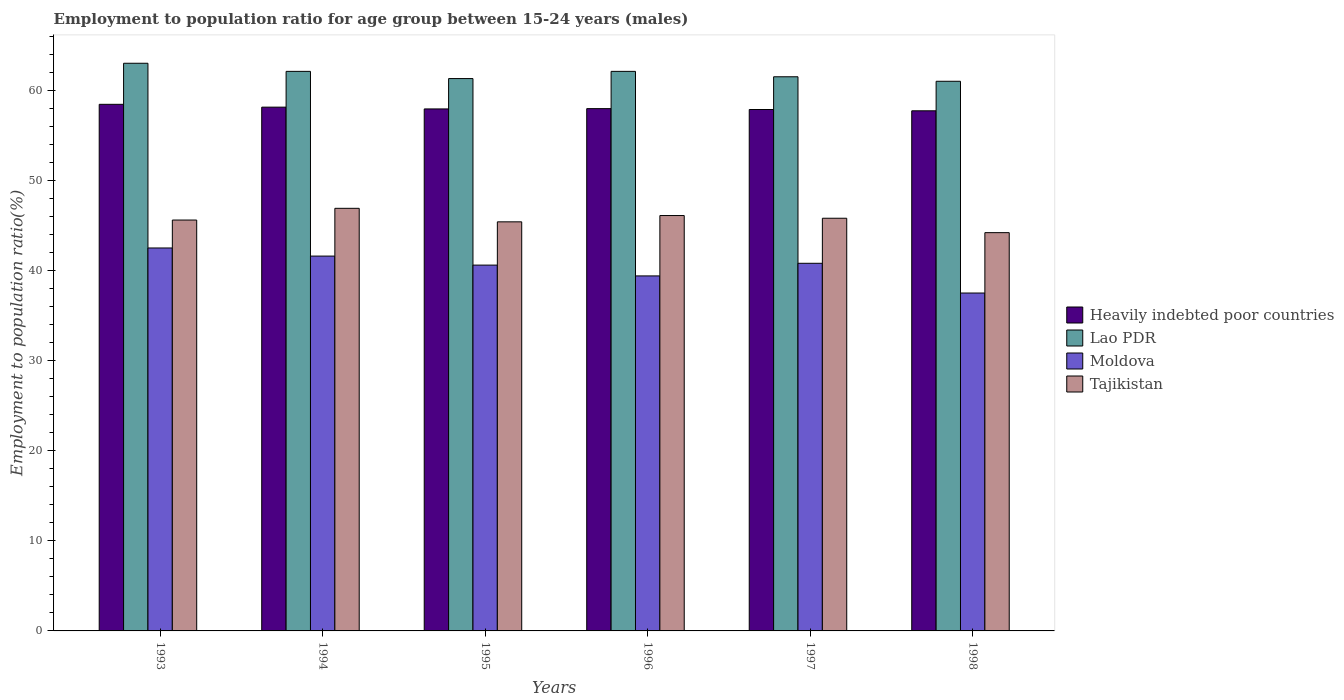Are the number of bars per tick equal to the number of legend labels?
Your answer should be very brief. Yes. Are the number of bars on each tick of the X-axis equal?
Make the answer very short. Yes. How many bars are there on the 4th tick from the left?
Provide a short and direct response. 4. What is the label of the 5th group of bars from the left?
Offer a very short reply. 1997. In how many cases, is the number of bars for a given year not equal to the number of legend labels?
Your response must be concise. 0. What is the employment to population ratio in Tajikistan in 1995?
Your answer should be very brief. 45.4. Across all years, what is the maximum employment to population ratio in Tajikistan?
Make the answer very short. 46.9. Across all years, what is the minimum employment to population ratio in Moldova?
Make the answer very short. 37.5. In which year was the employment to population ratio in Moldova maximum?
Give a very brief answer. 1993. What is the total employment to population ratio in Tajikistan in the graph?
Make the answer very short. 274. What is the difference between the employment to population ratio in Lao PDR in 1994 and that in 1996?
Offer a terse response. 0. What is the difference between the employment to population ratio in Moldova in 1998 and the employment to population ratio in Lao PDR in 1996?
Offer a terse response. -24.6. What is the average employment to population ratio in Moldova per year?
Your answer should be very brief. 40.4. In the year 1996, what is the difference between the employment to population ratio in Lao PDR and employment to population ratio in Heavily indebted poor countries?
Provide a succinct answer. 4.14. In how many years, is the employment to population ratio in Moldova greater than 22 %?
Make the answer very short. 6. What is the ratio of the employment to population ratio in Lao PDR in 1993 to that in 1998?
Provide a short and direct response. 1.03. What is the difference between the highest and the second highest employment to population ratio in Heavily indebted poor countries?
Ensure brevity in your answer.  0.31. What is the difference between the highest and the lowest employment to population ratio in Moldova?
Ensure brevity in your answer.  5. Is the sum of the employment to population ratio in Heavily indebted poor countries in 1993 and 1996 greater than the maximum employment to population ratio in Lao PDR across all years?
Offer a very short reply. Yes. Is it the case that in every year, the sum of the employment to population ratio in Moldova and employment to population ratio in Lao PDR is greater than the sum of employment to population ratio in Tajikistan and employment to population ratio in Heavily indebted poor countries?
Your response must be concise. No. What does the 1st bar from the left in 1997 represents?
Give a very brief answer. Heavily indebted poor countries. What does the 4th bar from the right in 1996 represents?
Make the answer very short. Heavily indebted poor countries. Are all the bars in the graph horizontal?
Keep it short and to the point. No. How many years are there in the graph?
Provide a short and direct response. 6. Where does the legend appear in the graph?
Provide a succinct answer. Center right. How many legend labels are there?
Give a very brief answer. 4. How are the legend labels stacked?
Your response must be concise. Vertical. What is the title of the graph?
Provide a succinct answer. Employment to population ratio for age group between 15-24 years (males). What is the Employment to population ratio(%) in Heavily indebted poor countries in 1993?
Your answer should be very brief. 58.44. What is the Employment to population ratio(%) of Moldova in 1993?
Offer a terse response. 42.5. What is the Employment to population ratio(%) in Tajikistan in 1993?
Offer a terse response. 45.6. What is the Employment to population ratio(%) of Heavily indebted poor countries in 1994?
Your answer should be very brief. 58.13. What is the Employment to population ratio(%) of Lao PDR in 1994?
Keep it short and to the point. 62.1. What is the Employment to population ratio(%) in Moldova in 1994?
Offer a terse response. 41.6. What is the Employment to population ratio(%) of Tajikistan in 1994?
Provide a succinct answer. 46.9. What is the Employment to population ratio(%) of Heavily indebted poor countries in 1995?
Keep it short and to the point. 57.93. What is the Employment to population ratio(%) in Lao PDR in 1995?
Provide a short and direct response. 61.3. What is the Employment to population ratio(%) of Moldova in 1995?
Provide a succinct answer. 40.6. What is the Employment to population ratio(%) in Tajikistan in 1995?
Offer a terse response. 45.4. What is the Employment to population ratio(%) in Heavily indebted poor countries in 1996?
Offer a very short reply. 57.96. What is the Employment to population ratio(%) of Lao PDR in 1996?
Your answer should be very brief. 62.1. What is the Employment to population ratio(%) in Moldova in 1996?
Offer a very short reply. 39.4. What is the Employment to population ratio(%) of Tajikistan in 1996?
Provide a short and direct response. 46.1. What is the Employment to population ratio(%) in Heavily indebted poor countries in 1997?
Your answer should be very brief. 57.87. What is the Employment to population ratio(%) in Lao PDR in 1997?
Provide a succinct answer. 61.5. What is the Employment to population ratio(%) in Moldova in 1997?
Your answer should be very brief. 40.8. What is the Employment to population ratio(%) of Tajikistan in 1997?
Your response must be concise. 45.8. What is the Employment to population ratio(%) of Heavily indebted poor countries in 1998?
Your response must be concise. 57.72. What is the Employment to population ratio(%) in Moldova in 1998?
Give a very brief answer. 37.5. What is the Employment to population ratio(%) in Tajikistan in 1998?
Offer a terse response. 44.2. Across all years, what is the maximum Employment to population ratio(%) in Heavily indebted poor countries?
Provide a short and direct response. 58.44. Across all years, what is the maximum Employment to population ratio(%) of Moldova?
Your response must be concise. 42.5. Across all years, what is the maximum Employment to population ratio(%) of Tajikistan?
Make the answer very short. 46.9. Across all years, what is the minimum Employment to population ratio(%) in Heavily indebted poor countries?
Keep it short and to the point. 57.72. Across all years, what is the minimum Employment to population ratio(%) in Lao PDR?
Keep it short and to the point. 61. Across all years, what is the minimum Employment to population ratio(%) in Moldova?
Your answer should be very brief. 37.5. Across all years, what is the minimum Employment to population ratio(%) in Tajikistan?
Your answer should be very brief. 44.2. What is the total Employment to population ratio(%) of Heavily indebted poor countries in the graph?
Offer a very short reply. 348.06. What is the total Employment to population ratio(%) in Lao PDR in the graph?
Offer a terse response. 371. What is the total Employment to population ratio(%) of Moldova in the graph?
Provide a succinct answer. 242.4. What is the total Employment to population ratio(%) in Tajikistan in the graph?
Offer a terse response. 274. What is the difference between the Employment to population ratio(%) in Heavily indebted poor countries in 1993 and that in 1994?
Offer a terse response. 0.31. What is the difference between the Employment to population ratio(%) of Moldova in 1993 and that in 1994?
Give a very brief answer. 0.9. What is the difference between the Employment to population ratio(%) in Heavily indebted poor countries in 1993 and that in 1995?
Give a very brief answer. 0.51. What is the difference between the Employment to population ratio(%) in Heavily indebted poor countries in 1993 and that in 1996?
Your answer should be compact. 0.48. What is the difference between the Employment to population ratio(%) of Lao PDR in 1993 and that in 1996?
Your answer should be compact. 0.9. What is the difference between the Employment to population ratio(%) of Tajikistan in 1993 and that in 1996?
Make the answer very short. -0.5. What is the difference between the Employment to population ratio(%) in Heavily indebted poor countries in 1993 and that in 1997?
Give a very brief answer. 0.57. What is the difference between the Employment to population ratio(%) of Lao PDR in 1993 and that in 1997?
Offer a very short reply. 1.5. What is the difference between the Employment to population ratio(%) of Heavily indebted poor countries in 1993 and that in 1998?
Provide a short and direct response. 0.72. What is the difference between the Employment to population ratio(%) in Tajikistan in 1993 and that in 1998?
Your answer should be very brief. 1.4. What is the difference between the Employment to population ratio(%) of Heavily indebted poor countries in 1994 and that in 1995?
Ensure brevity in your answer.  0.2. What is the difference between the Employment to population ratio(%) in Moldova in 1994 and that in 1995?
Provide a succinct answer. 1. What is the difference between the Employment to population ratio(%) in Heavily indebted poor countries in 1994 and that in 1996?
Ensure brevity in your answer.  0.16. What is the difference between the Employment to population ratio(%) of Lao PDR in 1994 and that in 1996?
Keep it short and to the point. 0. What is the difference between the Employment to population ratio(%) of Moldova in 1994 and that in 1996?
Your response must be concise. 2.2. What is the difference between the Employment to population ratio(%) in Tajikistan in 1994 and that in 1996?
Your answer should be very brief. 0.8. What is the difference between the Employment to population ratio(%) of Heavily indebted poor countries in 1994 and that in 1997?
Keep it short and to the point. 0.26. What is the difference between the Employment to population ratio(%) in Lao PDR in 1994 and that in 1997?
Your response must be concise. 0.6. What is the difference between the Employment to population ratio(%) of Moldova in 1994 and that in 1997?
Your answer should be very brief. 0.8. What is the difference between the Employment to population ratio(%) in Tajikistan in 1994 and that in 1997?
Keep it short and to the point. 1.1. What is the difference between the Employment to population ratio(%) of Heavily indebted poor countries in 1994 and that in 1998?
Give a very brief answer. 0.41. What is the difference between the Employment to population ratio(%) of Moldova in 1994 and that in 1998?
Your response must be concise. 4.1. What is the difference between the Employment to population ratio(%) in Tajikistan in 1994 and that in 1998?
Provide a short and direct response. 2.7. What is the difference between the Employment to population ratio(%) of Heavily indebted poor countries in 1995 and that in 1996?
Your response must be concise. -0.03. What is the difference between the Employment to population ratio(%) of Tajikistan in 1995 and that in 1996?
Your answer should be very brief. -0.7. What is the difference between the Employment to population ratio(%) of Heavily indebted poor countries in 1995 and that in 1997?
Make the answer very short. 0.06. What is the difference between the Employment to population ratio(%) of Lao PDR in 1995 and that in 1997?
Your answer should be compact. -0.2. What is the difference between the Employment to population ratio(%) of Moldova in 1995 and that in 1997?
Ensure brevity in your answer.  -0.2. What is the difference between the Employment to population ratio(%) in Tajikistan in 1995 and that in 1997?
Your answer should be compact. -0.4. What is the difference between the Employment to population ratio(%) in Heavily indebted poor countries in 1995 and that in 1998?
Keep it short and to the point. 0.21. What is the difference between the Employment to population ratio(%) in Moldova in 1995 and that in 1998?
Keep it short and to the point. 3.1. What is the difference between the Employment to population ratio(%) in Tajikistan in 1995 and that in 1998?
Your answer should be compact. 1.2. What is the difference between the Employment to population ratio(%) in Heavily indebted poor countries in 1996 and that in 1997?
Offer a very short reply. 0.1. What is the difference between the Employment to population ratio(%) of Lao PDR in 1996 and that in 1997?
Provide a short and direct response. 0.6. What is the difference between the Employment to population ratio(%) in Moldova in 1996 and that in 1997?
Ensure brevity in your answer.  -1.4. What is the difference between the Employment to population ratio(%) of Tajikistan in 1996 and that in 1997?
Provide a short and direct response. 0.3. What is the difference between the Employment to population ratio(%) of Heavily indebted poor countries in 1996 and that in 1998?
Provide a short and direct response. 0.24. What is the difference between the Employment to population ratio(%) in Lao PDR in 1996 and that in 1998?
Give a very brief answer. 1.1. What is the difference between the Employment to population ratio(%) of Moldova in 1996 and that in 1998?
Your answer should be very brief. 1.9. What is the difference between the Employment to population ratio(%) of Tajikistan in 1996 and that in 1998?
Your answer should be very brief. 1.9. What is the difference between the Employment to population ratio(%) in Heavily indebted poor countries in 1997 and that in 1998?
Your response must be concise. 0.14. What is the difference between the Employment to population ratio(%) in Lao PDR in 1997 and that in 1998?
Your response must be concise. 0.5. What is the difference between the Employment to population ratio(%) of Moldova in 1997 and that in 1998?
Ensure brevity in your answer.  3.3. What is the difference between the Employment to population ratio(%) in Tajikistan in 1997 and that in 1998?
Ensure brevity in your answer.  1.6. What is the difference between the Employment to population ratio(%) in Heavily indebted poor countries in 1993 and the Employment to population ratio(%) in Lao PDR in 1994?
Your answer should be very brief. -3.66. What is the difference between the Employment to population ratio(%) in Heavily indebted poor countries in 1993 and the Employment to population ratio(%) in Moldova in 1994?
Your answer should be compact. 16.84. What is the difference between the Employment to population ratio(%) of Heavily indebted poor countries in 1993 and the Employment to population ratio(%) of Tajikistan in 1994?
Offer a terse response. 11.54. What is the difference between the Employment to population ratio(%) of Lao PDR in 1993 and the Employment to population ratio(%) of Moldova in 1994?
Your response must be concise. 21.4. What is the difference between the Employment to population ratio(%) in Moldova in 1993 and the Employment to population ratio(%) in Tajikistan in 1994?
Provide a short and direct response. -4.4. What is the difference between the Employment to population ratio(%) in Heavily indebted poor countries in 1993 and the Employment to population ratio(%) in Lao PDR in 1995?
Offer a terse response. -2.86. What is the difference between the Employment to population ratio(%) in Heavily indebted poor countries in 1993 and the Employment to population ratio(%) in Moldova in 1995?
Ensure brevity in your answer.  17.84. What is the difference between the Employment to population ratio(%) of Heavily indebted poor countries in 1993 and the Employment to population ratio(%) of Tajikistan in 1995?
Give a very brief answer. 13.04. What is the difference between the Employment to population ratio(%) in Lao PDR in 1993 and the Employment to population ratio(%) in Moldova in 1995?
Offer a terse response. 22.4. What is the difference between the Employment to population ratio(%) of Heavily indebted poor countries in 1993 and the Employment to population ratio(%) of Lao PDR in 1996?
Offer a terse response. -3.66. What is the difference between the Employment to population ratio(%) of Heavily indebted poor countries in 1993 and the Employment to population ratio(%) of Moldova in 1996?
Provide a short and direct response. 19.04. What is the difference between the Employment to population ratio(%) of Heavily indebted poor countries in 1993 and the Employment to population ratio(%) of Tajikistan in 1996?
Your response must be concise. 12.34. What is the difference between the Employment to population ratio(%) of Lao PDR in 1993 and the Employment to population ratio(%) of Moldova in 1996?
Give a very brief answer. 23.6. What is the difference between the Employment to population ratio(%) of Lao PDR in 1993 and the Employment to population ratio(%) of Tajikistan in 1996?
Your response must be concise. 16.9. What is the difference between the Employment to population ratio(%) in Heavily indebted poor countries in 1993 and the Employment to population ratio(%) in Lao PDR in 1997?
Make the answer very short. -3.06. What is the difference between the Employment to population ratio(%) of Heavily indebted poor countries in 1993 and the Employment to population ratio(%) of Moldova in 1997?
Offer a very short reply. 17.64. What is the difference between the Employment to population ratio(%) in Heavily indebted poor countries in 1993 and the Employment to population ratio(%) in Tajikistan in 1997?
Offer a very short reply. 12.64. What is the difference between the Employment to population ratio(%) in Heavily indebted poor countries in 1993 and the Employment to population ratio(%) in Lao PDR in 1998?
Your answer should be compact. -2.56. What is the difference between the Employment to population ratio(%) of Heavily indebted poor countries in 1993 and the Employment to population ratio(%) of Moldova in 1998?
Make the answer very short. 20.94. What is the difference between the Employment to population ratio(%) in Heavily indebted poor countries in 1993 and the Employment to population ratio(%) in Tajikistan in 1998?
Offer a terse response. 14.24. What is the difference between the Employment to population ratio(%) of Heavily indebted poor countries in 1994 and the Employment to population ratio(%) of Lao PDR in 1995?
Give a very brief answer. -3.17. What is the difference between the Employment to population ratio(%) of Heavily indebted poor countries in 1994 and the Employment to population ratio(%) of Moldova in 1995?
Give a very brief answer. 17.53. What is the difference between the Employment to population ratio(%) in Heavily indebted poor countries in 1994 and the Employment to population ratio(%) in Tajikistan in 1995?
Offer a terse response. 12.73. What is the difference between the Employment to population ratio(%) in Lao PDR in 1994 and the Employment to population ratio(%) in Moldova in 1995?
Give a very brief answer. 21.5. What is the difference between the Employment to population ratio(%) in Moldova in 1994 and the Employment to population ratio(%) in Tajikistan in 1995?
Offer a very short reply. -3.8. What is the difference between the Employment to population ratio(%) in Heavily indebted poor countries in 1994 and the Employment to population ratio(%) in Lao PDR in 1996?
Ensure brevity in your answer.  -3.97. What is the difference between the Employment to population ratio(%) of Heavily indebted poor countries in 1994 and the Employment to population ratio(%) of Moldova in 1996?
Provide a succinct answer. 18.73. What is the difference between the Employment to population ratio(%) in Heavily indebted poor countries in 1994 and the Employment to population ratio(%) in Tajikistan in 1996?
Your answer should be compact. 12.03. What is the difference between the Employment to population ratio(%) in Lao PDR in 1994 and the Employment to population ratio(%) in Moldova in 1996?
Your response must be concise. 22.7. What is the difference between the Employment to population ratio(%) of Heavily indebted poor countries in 1994 and the Employment to population ratio(%) of Lao PDR in 1997?
Offer a very short reply. -3.37. What is the difference between the Employment to population ratio(%) of Heavily indebted poor countries in 1994 and the Employment to population ratio(%) of Moldova in 1997?
Make the answer very short. 17.33. What is the difference between the Employment to population ratio(%) in Heavily indebted poor countries in 1994 and the Employment to population ratio(%) in Tajikistan in 1997?
Your answer should be very brief. 12.33. What is the difference between the Employment to population ratio(%) in Lao PDR in 1994 and the Employment to population ratio(%) in Moldova in 1997?
Provide a succinct answer. 21.3. What is the difference between the Employment to population ratio(%) of Heavily indebted poor countries in 1994 and the Employment to population ratio(%) of Lao PDR in 1998?
Provide a short and direct response. -2.87. What is the difference between the Employment to population ratio(%) in Heavily indebted poor countries in 1994 and the Employment to population ratio(%) in Moldova in 1998?
Offer a terse response. 20.63. What is the difference between the Employment to population ratio(%) of Heavily indebted poor countries in 1994 and the Employment to population ratio(%) of Tajikistan in 1998?
Your response must be concise. 13.93. What is the difference between the Employment to population ratio(%) of Lao PDR in 1994 and the Employment to population ratio(%) of Moldova in 1998?
Give a very brief answer. 24.6. What is the difference between the Employment to population ratio(%) of Moldova in 1994 and the Employment to population ratio(%) of Tajikistan in 1998?
Offer a terse response. -2.6. What is the difference between the Employment to population ratio(%) of Heavily indebted poor countries in 1995 and the Employment to population ratio(%) of Lao PDR in 1996?
Offer a terse response. -4.17. What is the difference between the Employment to population ratio(%) in Heavily indebted poor countries in 1995 and the Employment to population ratio(%) in Moldova in 1996?
Your response must be concise. 18.53. What is the difference between the Employment to population ratio(%) of Heavily indebted poor countries in 1995 and the Employment to population ratio(%) of Tajikistan in 1996?
Your answer should be compact. 11.83. What is the difference between the Employment to population ratio(%) of Lao PDR in 1995 and the Employment to population ratio(%) of Moldova in 1996?
Your response must be concise. 21.9. What is the difference between the Employment to population ratio(%) in Heavily indebted poor countries in 1995 and the Employment to population ratio(%) in Lao PDR in 1997?
Offer a terse response. -3.57. What is the difference between the Employment to population ratio(%) of Heavily indebted poor countries in 1995 and the Employment to population ratio(%) of Moldova in 1997?
Keep it short and to the point. 17.13. What is the difference between the Employment to population ratio(%) in Heavily indebted poor countries in 1995 and the Employment to population ratio(%) in Tajikistan in 1997?
Offer a terse response. 12.13. What is the difference between the Employment to population ratio(%) in Lao PDR in 1995 and the Employment to population ratio(%) in Moldova in 1997?
Your answer should be very brief. 20.5. What is the difference between the Employment to population ratio(%) of Lao PDR in 1995 and the Employment to population ratio(%) of Tajikistan in 1997?
Offer a very short reply. 15.5. What is the difference between the Employment to population ratio(%) in Heavily indebted poor countries in 1995 and the Employment to population ratio(%) in Lao PDR in 1998?
Your response must be concise. -3.07. What is the difference between the Employment to population ratio(%) of Heavily indebted poor countries in 1995 and the Employment to population ratio(%) of Moldova in 1998?
Your answer should be compact. 20.43. What is the difference between the Employment to population ratio(%) in Heavily indebted poor countries in 1995 and the Employment to population ratio(%) in Tajikistan in 1998?
Give a very brief answer. 13.73. What is the difference between the Employment to population ratio(%) in Lao PDR in 1995 and the Employment to population ratio(%) in Moldova in 1998?
Offer a terse response. 23.8. What is the difference between the Employment to population ratio(%) in Lao PDR in 1995 and the Employment to population ratio(%) in Tajikistan in 1998?
Offer a terse response. 17.1. What is the difference between the Employment to population ratio(%) in Moldova in 1995 and the Employment to population ratio(%) in Tajikistan in 1998?
Offer a terse response. -3.6. What is the difference between the Employment to population ratio(%) of Heavily indebted poor countries in 1996 and the Employment to population ratio(%) of Lao PDR in 1997?
Give a very brief answer. -3.54. What is the difference between the Employment to population ratio(%) of Heavily indebted poor countries in 1996 and the Employment to population ratio(%) of Moldova in 1997?
Keep it short and to the point. 17.16. What is the difference between the Employment to population ratio(%) in Heavily indebted poor countries in 1996 and the Employment to population ratio(%) in Tajikistan in 1997?
Provide a short and direct response. 12.16. What is the difference between the Employment to population ratio(%) of Lao PDR in 1996 and the Employment to population ratio(%) of Moldova in 1997?
Offer a very short reply. 21.3. What is the difference between the Employment to population ratio(%) of Heavily indebted poor countries in 1996 and the Employment to population ratio(%) of Lao PDR in 1998?
Offer a very short reply. -3.04. What is the difference between the Employment to population ratio(%) in Heavily indebted poor countries in 1996 and the Employment to population ratio(%) in Moldova in 1998?
Provide a succinct answer. 20.46. What is the difference between the Employment to population ratio(%) of Heavily indebted poor countries in 1996 and the Employment to population ratio(%) of Tajikistan in 1998?
Offer a very short reply. 13.76. What is the difference between the Employment to population ratio(%) of Lao PDR in 1996 and the Employment to population ratio(%) of Moldova in 1998?
Offer a very short reply. 24.6. What is the difference between the Employment to population ratio(%) in Lao PDR in 1996 and the Employment to population ratio(%) in Tajikistan in 1998?
Your answer should be compact. 17.9. What is the difference between the Employment to population ratio(%) in Moldova in 1996 and the Employment to population ratio(%) in Tajikistan in 1998?
Your answer should be very brief. -4.8. What is the difference between the Employment to population ratio(%) in Heavily indebted poor countries in 1997 and the Employment to population ratio(%) in Lao PDR in 1998?
Your answer should be compact. -3.13. What is the difference between the Employment to population ratio(%) in Heavily indebted poor countries in 1997 and the Employment to population ratio(%) in Moldova in 1998?
Make the answer very short. 20.37. What is the difference between the Employment to population ratio(%) of Heavily indebted poor countries in 1997 and the Employment to population ratio(%) of Tajikistan in 1998?
Ensure brevity in your answer.  13.67. What is the difference between the Employment to population ratio(%) in Lao PDR in 1997 and the Employment to population ratio(%) in Moldova in 1998?
Provide a short and direct response. 24. What is the average Employment to population ratio(%) of Heavily indebted poor countries per year?
Ensure brevity in your answer.  58.01. What is the average Employment to population ratio(%) in Lao PDR per year?
Make the answer very short. 61.83. What is the average Employment to population ratio(%) of Moldova per year?
Your response must be concise. 40.4. What is the average Employment to population ratio(%) of Tajikistan per year?
Your response must be concise. 45.67. In the year 1993, what is the difference between the Employment to population ratio(%) of Heavily indebted poor countries and Employment to population ratio(%) of Lao PDR?
Provide a succinct answer. -4.56. In the year 1993, what is the difference between the Employment to population ratio(%) in Heavily indebted poor countries and Employment to population ratio(%) in Moldova?
Provide a succinct answer. 15.94. In the year 1993, what is the difference between the Employment to population ratio(%) in Heavily indebted poor countries and Employment to population ratio(%) in Tajikistan?
Give a very brief answer. 12.84. In the year 1993, what is the difference between the Employment to population ratio(%) of Moldova and Employment to population ratio(%) of Tajikistan?
Keep it short and to the point. -3.1. In the year 1994, what is the difference between the Employment to population ratio(%) of Heavily indebted poor countries and Employment to population ratio(%) of Lao PDR?
Give a very brief answer. -3.97. In the year 1994, what is the difference between the Employment to population ratio(%) of Heavily indebted poor countries and Employment to population ratio(%) of Moldova?
Provide a short and direct response. 16.53. In the year 1994, what is the difference between the Employment to population ratio(%) in Heavily indebted poor countries and Employment to population ratio(%) in Tajikistan?
Your answer should be compact. 11.23. In the year 1994, what is the difference between the Employment to population ratio(%) in Moldova and Employment to population ratio(%) in Tajikistan?
Your answer should be compact. -5.3. In the year 1995, what is the difference between the Employment to population ratio(%) in Heavily indebted poor countries and Employment to population ratio(%) in Lao PDR?
Provide a short and direct response. -3.37. In the year 1995, what is the difference between the Employment to population ratio(%) in Heavily indebted poor countries and Employment to population ratio(%) in Moldova?
Keep it short and to the point. 17.33. In the year 1995, what is the difference between the Employment to population ratio(%) of Heavily indebted poor countries and Employment to population ratio(%) of Tajikistan?
Make the answer very short. 12.53. In the year 1995, what is the difference between the Employment to population ratio(%) of Lao PDR and Employment to population ratio(%) of Moldova?
Make the answer very short. 20.7. In the year 1996, what is the difference between the Employment to population ratio(%) in Heavily indebted poor countries and Employment to population ratio(%) in Lao PDR?
Your response must be concise. -4.14. In the year 1996, what is the difference between the Employment to population ratio(%) in Heavily indebted poor countries and Employment to population ratio(%) in Moldova?
Offer a very short reply. 18.56. In the year 1996, what is the difference between the Employment to population ratio(%) of Heavily indebted poor countries and Employment to population ratio(%) of Tajikistan?
Offer a very short reply. 11.86. In the year 1996, what is the difference between the Employment to population ratio(%) in Lao PDR and Employment to population ratio(%) in Moldova?
Ensure brevity in your answer.  22.7. In the year 1996, what is the difference between the Employment to population ratio(%) in Moldova and Employment to population ratio(%) in Tajikistan?
Your answer should be very brief. -6.7. In the year 1997, what is the difference between the Employment to population ratio(%) in Heavily indebted poor countries and Employment to population ratio(%) in Lao PDR?
Provide a succinct answer. -3.63. In the year 1997, what is the difference between the Employment to population ratio(%) in Heavily indebted poor countries and Employment to population ratio(%) in Moldova?
Ensure brevity in your answer.  17.07. In the year 1997, what is the difference between the Employment to population ratio(%) in Heavily indebted poor countries and Employment to population ratio(%) in Tajikistan?
Give a very brief answer. 12.07. In the year 1997, what is the difference between the Employment to population ratio(%) in Lao PDR and Employment to population ratio(%) in Moldova?
Provide a short and direct response. 20.7. In the year 1997, what is the difference between the Employment to population ratio(%) in Lao PDR and Employment to population ratio(%) in Tajikistan?
Offer a terse response. 15.7. In the year 1997, what is the difference between the Employment to population ratio(%) in Moldova and Employment to population ratio(%) in Tajikistan?
Offer a very short reply. -5. In the year 1998, what is the difference between the Employment to population ratio(%) of Heavily indebted poor countries and Employment to population ratio(%) of Lao PDR?
Provide a succinct answer. -3.28. In the year 1998, what is the difference between the Employment to population ratio(%) in Heavily indebted poor countries and Employment to population ratio(%) in Moldova?
Ensure brevity in your answer.  20.22. In the year 1998, what is the difference between the Employment to population ratio(%) of Heavily indebted poor countries and Employment to population ratio(%) of Tajikistan?
Offer a terse response. 13.52. In the year 1998, what is the difference between the Employment to population ratio(%) in Lao PDR and Employment to population ratio(%) in Moldova?
Your response must be concise. 23.5. In the year 1998, what is the difference between the Employment to population ratio(%) of Moldova and Employment to population ratio(%) of Tajikistan?
Make the answer very short. -6.7. What is the ratio of the Employment to population ratio(%) of Heavily indebted poor countries in 1993 to that in 1994?
Give a very brief answer. 1.01. What is the ratio of the Employment to population ratio(%) of Lao PDR in 1993 to that in 1994?
Your response must be concise. 1.01. What is the ratio of the Employment to population ratio(%) in Moldova in 1993 to that in 1994?
Ensure brevity in your answer.  1.02. What is the ratio of the Employment to population ratio(%) of Tajikistan in 1993 to that in 1994?
Ensure brevity in your answer.  0.97. What is the ratio of the Employment to population ratio(%) of Heavily indebted poor countries in 1993 to that in 1995?
Provide a short and direct response. 1.01. What is the ratio of the Employment to population ratio(%) in Lao PDR in 1993 to that in 1995?
Keep it short and to the point. 1.03. What is the ratio of the Employment to population ratio(%) in Moldova in 1993 to that in 1995?
Ensure brevity in your answer.  1.05. What is the ratio of the Employment to population ratio(%) in Heavily indebted poor countries in 1993 to that in 1996?
Your answer should be compact. 1.01. What is the ratio of the Employment to population ratio(%) of Lao PDR in 1993 to that in 1996?
Your response must be concise. 1.01. What is the ratio of the Employment to population ratio(%) of Moldova in 1993 to that in 1996?
Your answer should be compact. 1.08. What is the ratio of the Employment to population ratio(%) of Tajikistan in 1993 to that in 1996?
Make the answer very short. 0.99. What is the ratio of the Employment to population ratio(%) of Heavily indebted poor countries in 1993 to that in 1997?
Your response must be concise. 1.01. What is the ratio of the Employment to population ratio(%) in Lao PDR in 1993 to that in 1997?
Provide a short and direct response. 1.02. What is the ratio of the Employment to population ratio(%) in Moldova in 1993 to that in 1997?
Your answer should be compact. 1.04. What is the ratio of the Employment to population ratio(%) in Heavily indebted poor countries in 1993 to that in 1998?
Offer a terse response. 1.01. What is the ratio of the Employment to population ratio(%) of Lao PDR in 1993 to that in 1998?
Your response must be concise. 1.03. What is the ratio of the Employment to population ratio(%) in Moldova in 1993 to that in 1998?
Your answer should be compact. 1.13. What is the ratio of the Employment to population ratio(%) in Tajikistan in 1993 to that in 1998?
Ensure brevity in your answer.  1.03. What is the ratio of the Employment to population ratio(%) of Lao PDR in 1994 to that in 1995?
Ensure brevity in your answer.  1.01. What is the ratio of the Employment to population ratio(%) of Moldova in 1994 to that in 1995?
Keep it short and to the point. 1.02. What is the ratio of the Employment to population ratio(%) of Tajikistan in 1994 to that in 1995?
Keep it short and to the point. 1.03. What is the ratio of the Employment to population ratio(%) of Moldova in 1994 to that in 1996?
Ensure brevity in your answer.  1.06. What is the ratio of the Employment to population ratio(%) of Tajikistan in 1994 to that in 1996?
Keep it short and to the point. 1.02. What is the ratio of the Employment to population ratio(%) in Heavily indebted poor countries in 1994 to that in 1997?
Offer a terse response. 1. What is the ratio of the Employment to population ratio(%) in Lao PDR in 1994 to that in 1997?
Keep it short and to the point. 1.01. What is the ratio of the Employment to population ratio(%) of Moldova in 1994 to that in 1997?
Provide a succinct answer. 1.02. What is the ratio of the Employment to population ratio(%) in Lao PDR in 1994 to that in 1998?
Offer a terse response. 1.02. What is the ratio of the Employment to population ratio(%) in Moldova in 1994 to that in 1998?
Provide a short and direct response. 1.11. What is the ratio of the Employment to population ratio(%) in Tajikistan in 1994 to that in 1998?
Ensure brevity in your answer.  1.06. What is the ratio of the Employment to population ratio(%) in Lao PDR in 1995 to that in 1996?
Keep it short and to the point. 0.99. What is the ratio of the Employment to population ratio(%) in Moldova in 1995 to that in 1996?
Ensure brevity in your answer.  1.03. What is the ratio of the Employment to population ratio(%) in Tajikistan in 1995 to that in 1996?
Make the answer very short. 0.98. What is the ratio of the Employment to population ratio(%) of Moldova in 1995 to that in 1997?
Your response must be concise. 1. What is the ratio of the Employment to population ratio(%) of Tajikistan in 1995 to that in 1997?
Your answer should be compact. 0.99. What is the ratio of the Employment to population ratio(%) in Heavily indebted poor countries in 1995 to that in 1998?
Provide a short and direct response. 1. What is the ratio of the Employment to population ratio(%) of Moldova in 1995 to that in 1998?
Your response must be concise. 1.08. What is the ratio of the Employment to population ratio(%) in Tajikistan in 1995 to that in 1998?
Give a very brief answer. 1.03. What is the ratio of the Employment to population ratio(%) of Lao PDR in 1996 to that in 1997?
Your answer should be very brief. 1.01. What is the ratio of the Employment to population ratio(%) of Moldova in 1996 to that in 1997?
Provide a short and direct response. 0.97. What is the ratio of the Employment to population ratio(%) in Tajikistan in 1996 to that in 1997?
Your response must be concise. 1.01. What is the ratio of the Employment to population ratio(%) in Heavily indebted poor countries in 1996 to that in 1998?
Offer a terse response. 1. What is the ratio of the Employment to population ratio(%) in Lao PDR in 1996 to that in 1998?
Your answer should be very brief. 1.02. What is the ratio of the Employment to population ratio(%) of Moldova in 1996 to that in 1998?
Your response must be concise. 1.05. What is the ratio of the Employment to population ratio(%) of Tajikistan in 1996 to that in 1998?
Give a very brief answer. 1.04. What is the ratio of the Employment to population ratio(%) in Lao PDR in 1997 to that in 1998?
Provide a short and direct response. 1.01. What is the ratio of the Employment to population ratio(%) of Moldova in 1997 to that in 1998?
Your answer should be very brief. 1.09. What is the ratio of the Employment to population ratio(%) in Tajikistan in 1997 to that in 1998?
Your answer should be very brief. 1.04. What is the difference between the highest and the second highest Employment to population ratio(%) of Heavily indebted poor countries?
Keep it short and to the point. 0.31. What is the difference between the highest and the second highest Employment to population ratio(%) of Lao PDR?
Your answer should be very brief. 0.9. What is the difference between the highest and the lowest Employment to population ratio(%) in Heavily indebted poor countries?
Your response must be concise. 0.72. What is the difference between the highest and the lowest Employment to population ratio(%) of Lao PDR?
Make the answer very short. 2. What is the difference between the highest and the lowest Employment to population ratio(%) in Tajikistan?
Keep it short and to the point. 2.7. 